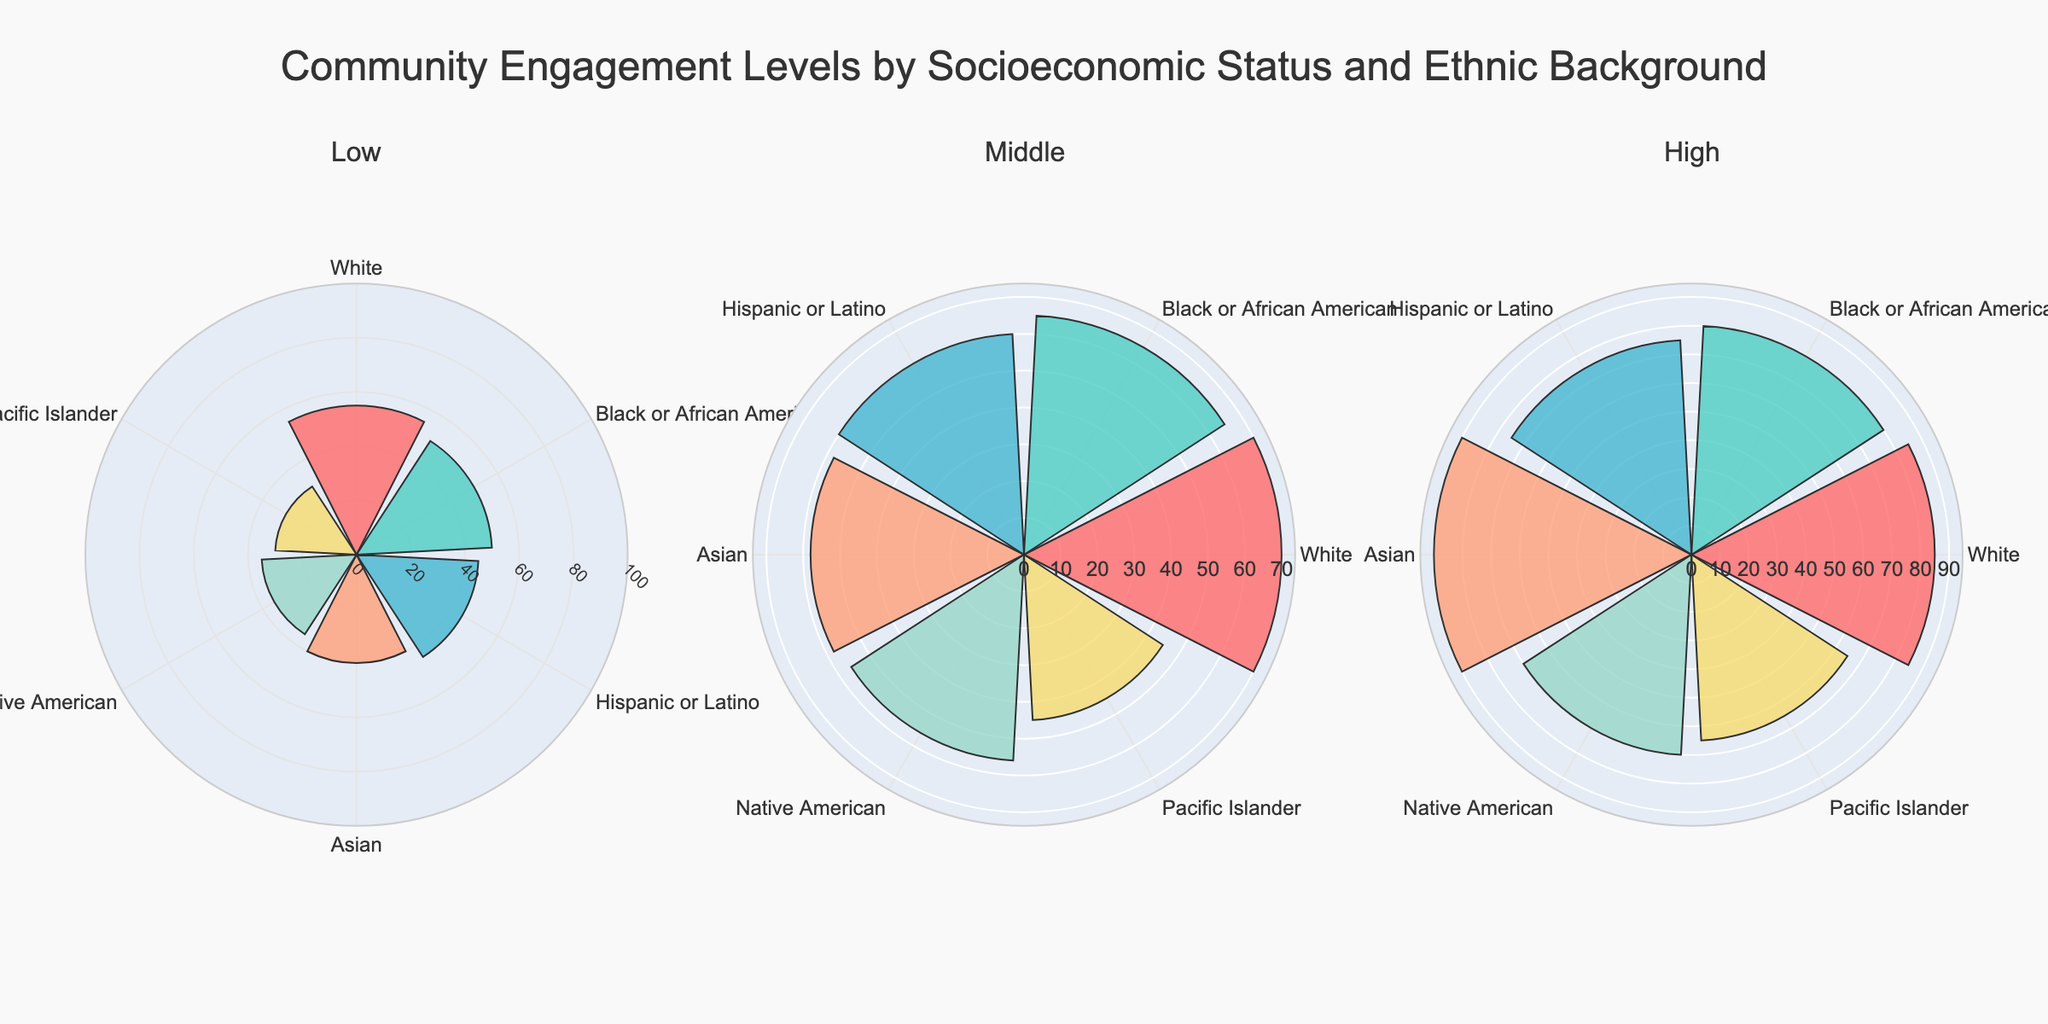What is the title of the plot? The title of the plot is usually displayed prominently at the top. Here, we can see a clear title above the subplots.
Answer: Community Engagement Levels by Socioeconomic Status and Ethnic Background How many subplots are displayed in the figure? There are three subplots in the figure, which can be identified by the distinct separation between them.
Answer: 3 Which socioeconomic status group has the highest community engagement level among Asians? By observing the darkest colored bar (each color represents an ethnic background including Asian) in each subplot, we can find the highest value for each group. For Asians in the "High" socioeconomic status group, the value is the highest compared to the "Middle" and "Low" groups.
Answer: High What is the difference in community engagement levels between Hispanic or Latino individuals in the Low and High socioeconomic status groups? Locate the bars corresponding to Hispanic or Latino in "Low" and "High" socioeconomic status groups, then subtract the value in "Low" from the value in "High". This is 75 - 45.
Answer: 30 Which ethnic background has the lowest community engagement level in the "Middle" socioeconomic status group? By examining the bars in the "Middle" socioeconomic status subplot, identify the smallest bar which corresponds to Pacific Islanders.
Answer: Pacific Islander What is the average community engagement level of White individuals across all socioeconomic statuses? Add up the community engagement levels of White individuals in all three subplots and divide by three. The values are 55, 70, and 85. The sum is 210, and the average is 210/3.
Answer: 70 Compare the community engagement levels of Black or African American individuals in the "Middle" and "High" socioeconomic status groups. Which is higher and by how much? Identify the bars corresponding to Black or African American in the "Middle" and "High" subplots and subtract the "Middle" value from the "High" value. The values are 80 (High) and 65 (Middle). The difference is 80 - 65.
Answer: High, by 15 Among White, Black or African American, and Asian individuals in the "Low" socioeconomic status group, who has the highest community engagement level? Compare the heights of the bars corresponding to White, Black or African American, and Asian individuals in the "Low" subplot. The order is White > Black or African American > Asian.
Answer: White What is the total community engagement level for all ethnic backgrounds in the "High" socioeconomic status group? Sum all the community engagement levels for ethnic backgrounds in the "High" socioeconomic status subplot. Add the values: 85 + 80 + 75 + 90 + 70 + 65. The sum is 465.
Answer: 465 